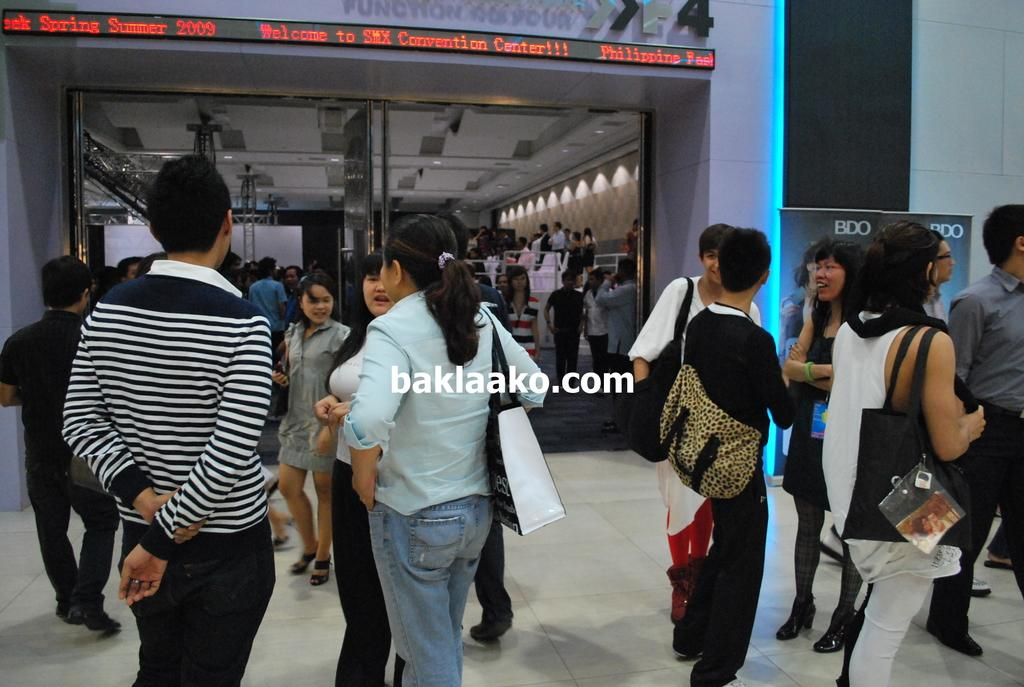How many people are in the group visible in the image? There is a group of people standing in the image, but the exact number cannot be determined from the provided facts. What surface are the people standing on? The people are standing on the floor. What can be seen through the glass door in the image? A crowd of people, lights, and a wall are visible through the door. What type of beam is holding up the ceiling in the image? There is no information about a ceiling or any beams in the image. What kind of bait is being used to catch fish in the image? There is no mention of fishing or bait in the image. 